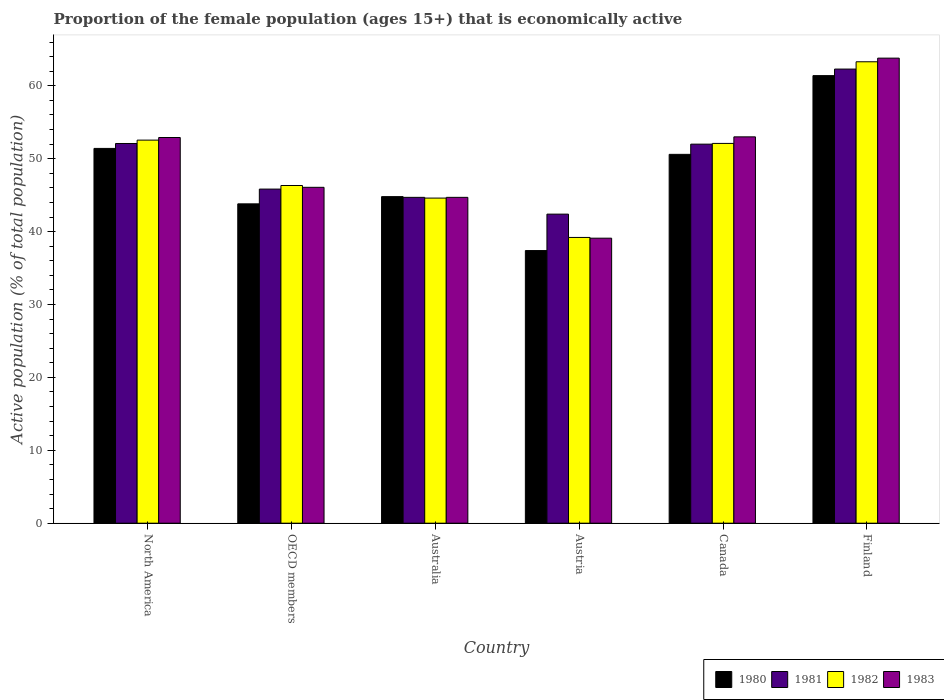How many different coloured bars are there?
Ensure brevity in your answer.  4. How many bars are there on the 3rd tick from the left?
Provide a short and direct response. 4. How many bars are there on the 3rd tick from the right?
Ensure brevity in your answer.  4. What is the label of the 3rd group of bars from the left?
Provide a succinct answer. Australia. In how many cases, is the number of bars for a given country not equal to the number of legend labels?
Ensure brevity in your answer.  0. What is the proportion of the female population that is economically active in 1983 in Canada?
Give a very brief answer. 53. Across all countries, what is the maximum proportion of the female population that is economically active in 1983?
Your response must be concise. 63.8. Across all countries, what is the minimum proportion of the female population that is economically active in 1980?
Provide a succinct answer. 37.4. In which country was the proportion of the female population that is economically active in 1983 maximum?
Your response must be concise. Finland. In which country was the proportion of the female population that is economically active in 1981 minimum?
Offer a very short reply. Austria. What is the total proportion of the female population that is economically active in 1980 in the graph?
Make the answer very short. 289.42. What is the difference between the proportion of the female population that is economically active in 1982 in Canada and that in OECD members?
Your answer should be compact. 5.78. What is the difference between the proportion of the female population that is economically active in 1982 in OECD members and the proportion of the female population that is economically active in 1983 in Canada?
Provide a succinct answer. -6.68. What is the average proportion of the female population that is economically active in 1983 per country?
Offer a very short reply. 49.93. What is the difference between the proportion of the female population that is economically active of/in 1983 and proportion of the female population that is economically active of/in 1982 in Australia?
Give a very brief answer. 0.1. In how many countries, is the proportion of the female population that is economically active in 1983 greater than 64 %?
Provide a succinct answer. 0. What is the ratio of the proportion of the female population that is economically active in 1980 in Finland to that in OECD members?
Offer a terse response. 1.4. Is the proportion of the female population that is economically active in 1981 in Finland less than that in OECD members?
Ensure brevity in your answer.  No. Is the difference between the proportion of the female population that is economically active in 1983 in Australia and Finland greater than the difference between the proportion of the female population that is economically active in 1982 in Australia and Finland?
Provide a short and direct response. No. What is the difference between the highest and the second highest proportion of the female population that is economically active in 1981?
Your response must be concise. -10.21. What is the difference between the highest and the lowest proportion of the female population that is economically active in 1982?
Provide a succinct answer. 24.1. In how many countries, is the proportion of the female population that is economically active in 1982 greater than the average proportion of the female population that is economically active in 1982 taken over all countries?
Offer a very short reply. 3. What does the 1st bar from the left in Australia represents?
Offer a very short reply. 1980. How many bars are there?
Offer a terse response. 24. Are all the bars in the graph horizontal?
Make the answer very short. No. How many countries are there in the graph?
Your response must be concise. 6. Does the graph contain any zero values?
Keep it short and to the point. No. Does the graph contain grids?
Ensure brevity in your answer.  No. How many legend labels are there?
Your answer should be compact. 4. What is the title of the graph?
Keep it short and to the point. Proportion of the female population (ages 15+) that is economically active. What is the label or title of the Y-axis?
Offer a very short reply. Active population (% of total population). What is the Active population (% of total population) in 1980 in North America?
Your answer should be very brief. 51.41. What is the Active population (% of total population) in 1981 in North America?
Provide a short and direct response. 52.09. What is the Active population (% of total population) in 1982 in North America?
Ensure brevity in your answer.  52.55. What is the Active population (% of total population) in 1983 in North America?
Your answer should be compact. 52.91. What is the Active population (% of total population) in 1980 in OECD members?
Offer a terse response. 43.81. What is the Active population (% of total population) in 1981 in OECD members?
Ensure brevity in your answer.  45.84. What is the Active population (% of total population) of 1982 in OECD members?
Your answer should be very brief. 46.32. What is the Active population (% of total population) in 1983 in OECD members?
Your answer should be very brief. 46.08. What is the Active population (% of total population) of 1980 in Australia?
Make the answer very short. 44.8. What is the Active population (% of total population) of 1981 in Australia?
Provide a succinct answer. 44.7. What is the Active population (% of total population) in 1982 in Australia?
Offer a very short reply. 44.6. What is the Active population (% of total population) in 1983 in Australia?
Provide a short and direct response. 44.7. What is the Active population (% of total population) of 1980 in Austria?
Your answer should be compact. 37.4. What is the Active population (% of total population) in 1981 in Austria?
Your answer should be compact. 42.4. What is the Active population (% of total population) of 1982 in Austria?
Provide a succinct answer. 39.2. What is the Active population (% of total population) in 1983 in Austria?
Provide a short and direct response. 39.1. What is the Active population (% of total population) in 1980 in Canada?
Make the answer very short. 50.6. What is the Active population (% of total population) in 1981 in Canada?
Give a very brief answer. 52. What is the Active population (% of total population) of 1982 in Canada?
Give a very brief answer. 52.1. What is the Active population (% of total population) in 1980 in Finland?
Offer a very short reply. 61.4. What is the Active population (% of total population) in 1981 in Finland?
Your answer should be very brief. 62.3. What is the Active population (% of total population) of 1982 in Finland?
Provide a succinct answer. 63.3. What is the Active population (% of total population) in 1983 in Finland?
Provide a short and direct response. 63.8. Across all countries, what is the maximum Active population (% of total population) of 1980?
Your answer should be compact. 61.4. Across all countries, what is the maximum Active population (% of total population) in 1981?
Offer a terse response. 62.3. Across all countries, what is the maximum Active population (% of total population) in 1982?
Offer a very short reply. 63.3. Across all countries, what is the maximum Active population (% of total population) in 1983?
Give a very brief answer. 63.8. Across all countries, what is the minimum Active population (% of total population) of 1980?
Provide a short and direct response. 37.4. Across all countries, what is the minimum Active population (% of total population) in 1981?
Your answer should be compact. 42.4. Across all countries, what is the minimum Active population (% of total population) of 1982?
Provide a short and direct response. 39.2. Across all countries, what is the minimum Active population (% of total population) of 1983?
Make the answer very short. 39.1. What is the total Active population (% of total population) of 1980 in the graph?
Your answer should be compact. 289.42. What is the total Active population (% of total population) in 1981 in the graph?
Ensure brevity in your answer.  299.33. What is the total Active population (% of total population) in 1982 in the graph?
Offer a very short reply. 298.08. What is the total Active population (% of total population) in 1983 in the graph?
Make the answer very short. 299.59. What is the difference between the Active population (% of total population) in 1980 in North America and that in OECD members?
Your answer should be compact. 7.61. What is the difference between the Active population (% of total population) in 1981 in North America and that in OECD members?
Provide a short and direct response. 6.25. What is the difference between the Active population (% of total population) in 1982 in North America and that in OECD members?
Provide a short and direct response. 6.23. What is the difference between the Active population (% of total population) of 1983 in North America and that in OECD members?
Offer a terse response. 6.83. What is the difference between the Active population (% of total population) in 1980 in North America and that in Australia?
Provide a succinct answer. 6.61. What is the difference between the Active population (% of total population) in 1981 in North America and that in Australia?
Your answer should be compact. 7.39. What is the difference between the Active population (% of total population) in 1982 in North America and that in Australia?
Offer a terse response. 7.95. What is the difference between the Active population (% of total population) of 1983 in North America and that in Australia?
Your response must be concise. 8.21. What is the difference between the Active population (% of total population) of 1980 in North America and that in Austria?
Keep it short and to the point. 14.01. What is the difference between the Active population (% of total population) in 1981 in North America and that in Austria?
Ensure brevity in your answer.  9.69. What is the difference between the Active population (% of total population) of 1982 in North America and that in Austria?
Provide a succinct answer. 13.35. What is the difference between the Active population (% of total population) in 1983 in North America and that in Austria?
Your answer should be compact. 13.81. What is the difference between the Active population (% of total population) of 1980 in North America and that in Canada?
Ensure brevity in your answer.  0.81. What is the difference between the Active population (% of total population) in 1981 in North America and that in Canada?
Your answer should be very brief. 0.09. What is the difference between the Active population (% of total population) in 1982 in North America and that in Canada?
Offer a very short reply. 0.45. What is the difference between the Active population (% of total population) in 1983 in North America and that in Canada?
Provide a short and direct response. -0.09. What is the difference between the Active population (% of total population) of 1980 in North America and that in Finland?
Ensure brevity in your answer.  -9.99. What is the difference between the Active population (% of total population) of 1981 in North America and that in Finland?
Ensure brevity in your answer.  -10.21. What is the difference between the Active population (% of total population) in 1982 in North America and that in Finland?
Your response must be concise. -10.75. What is the difference between the Active population (% of total population) of 1983 in North America and that in Finland?
Your answer should be compact. -10.89. What is the difference between the Active population (% of total population) in 1980 in OECD members and that in Australia?
Your response must be concise. -0.99. What is the difference between the Active population (% of total population) in 1981 in OECD members and that in Australia?
Your answer should be very brief. 1.14. What is the difference between the Active population (% of total population) of 1982 in OECD members and that in Australia?
Keep it short and to the point. 1.72. What is the difference between the Active population (% of total population) of 1983 in OECD members and that in Australia?
Your answer should be very brief. 1.38. What is the difference between the Active population (% of total population) of 1980 in OECD members and that in Austria?
Give a very brief answer. 6.41. What is the difference between the Active population (% of total population) in 1981 in OECD members and that in Austria?
Offer a very short reply. 3.44. What is the difference between the Active population (% of total population) in 1982 in OECD members and that in Austria?
Your response must be concise. 7.12. What is the difference between the Active population (% of total population) in 1983 in OECD members and that in Austria?
Your response must be concise. 6.98. What is the difference between the Active population (% of total population) of 1980 in OECD members and that in Canada?
Offer a very short reply. -6.79. What is the difference between the Active population (% of total population) in 1981 in OECD members and that in Canada?
Provide a short and direct response. -6.16. What is the difference between the Active population (% of total population) in 1982 in OECD members and that in Canada?
Provide a succinct answer. -5.78. What is the difference between the Active population (% of total population) of 1983 in OECD members and that in Canada?
Your response must be concise. -6.92. What is the difference between the Active population (% of total population) in 1980 in OECD members and that in Finland?
Give a very brief answer. -17.59. What is the difference between the Active population (% of total population) in 1981 in OECD members and that in Finland?
Give a very brief answer. -16.46. What is the difference between the Active population (% of total population) in 1982 in OECD members and that in Finland?
Your response must be concise. -16.98. What is the difference between the Active population (% of total population) in 1983 in OECD members and that in Finland?
Ensure brevity in your answer.  -17.72. What is the difference between the Active population (% of total population) of 1980 in Australia and that in Canada?
Give a very brief answer. -5.8. What is the difference between the Active population (% of total population) in 1980 in Australia and that in Finland?
Your response must be concise. -16.6. What is the difference between the Active population (% of total population) of 1981 in Australia and that in Finland?
Your answer should be very brief. -17.6. What is the difference between the Active population (% of total population) in 1982 in Australia and that in Finland?
Your answer should be very brief. -18.7. What is the difference between the Active population (% of total population) in 1983 in Australia and that in Finland?
Offer a very short reply. -19.1. What is the difference between the Active population (% of total population) in 1982 in Austria and that in Canada?
Make the answer very short. -12.9. What is the difference between the Active population (% of total population) of 1983 in Austria and that in Canada?
Keep it short and to the point. -13.9. What is the difference between the Active population (% of total population) of 1980 in Austria and that in Finland?
Offer a very short reply. -24. What is the difference between the Active population (% of total population) of 1981 in Austria and that in Finland?
Your answer should be compact. -19.9. What is the difference between the Active population (% of total population) in 1982 in Austria and that in Finland?
Your response must be concise. -24.1. What is the difference between the Active population (% of total population) of 1983 in Austria and that in Finland?
Your answer should be compact. -24.7. What is the difference between the Active population (% of total population) in 1980 in Canada and that in Finland?
Give a very brief answer. -10.8. What is the difference between the Active population (% of total population) of 1981 in Canada and that in Finland?
Give a very brief answer. -10.3. What is the difference between the Active population (% of total population) in 1980 in North America and the Active population (% of total population) in 1981 in OECD members?
Your answer should be very brief. 5.58. What is the difference between the Active population (% of total population) in 1980 in North America and the Active population (% of total population) in 1982 in OECD members?
Your answer should be compact. 5.09. What is the difference between the Active population (% of total population) of 1980 in North America and the Active population (% of total population) of 1983 in OECD members?
Your response must be concise. 5.34. What is the difference between the Active population (% of total population) in 1981 in North America and the Active population (% of total population) in 1982 in OECD members?
Keep it short and to the point. 5.77. What is the difference between the Active population (% of total population) of 1981 in North America and the Active population (% of total population) of 1983 in OECD members?
Your answer should be compact. 6.01. What is the difference between the Active population (% of total population) of 1982 in North America and the Active population (% of total population) of 1983 in OECD members?
Offer a terse response. 6.47. What is the difference between the Active population (% of total population) in 1980 in North America and the Active population (% of total population) in 1981 in Australia?
Your answer should be compact. 6.71. What is the difference between the Active population (% of total population) in 1980 in North America and the Active population (% of total population) in 1982 in Australia?
Make the answer very short. 6.81. What is the difference between the Active population (% of total population) in 1980 in North America and the Active population (% of total population) in 1983 in Australia?
Keep it short and to the point. 6.71. What is the difference between the Active population (% of total population) of 1981 in North America and the Active population (% of total population) of 1982 in Australia?
Make the answer very short. 7.49. What is the difference between the Active population (% of total population) of 1981 in North America and the Active population (% of total population) of 1983 in Australia?
Your answer should be compact. 7.39. What is the difference between the Active population (% of total population) in 1982 in North America and the Active population (% of total population) in 1983 in Australia?
Provide a succinct answer. 7.85. What is the difference between the Active population (% of total population) in 1980 in North America and the Active population (% of total population) in 1981 in Austria?
Provide a short and direct response. 9.01. What is the difference between the Active population (% of total population) of 1980 in North America and the Active population (% of total population) of 1982 in Austria?
Offer a terse response. 12.21. What is the difference between the Active population (% of total population) in 1980 in North America and the Active population (% of total population) in 1983 in Austria?
Provide a succinct answer. 12.31. What is the difference between the Active population (% of total population) in 1981 in North America and the Active population (% of total population) in 1982 in Austria?
Ensure brevity in your answer.  12.89. What is the difference between the Active population (% of total population) of 1981 in North America and the Active population (% of total population) of 1983 in Austria?
Your answer should be compact. 12.99. What is the difference between the Active population (% of total population) of 1982 in North America and the Active population (% of total population) of 1983 in Austria?
Provide a short and direct response. 13.45. What is the difference between the Active population (% of total population) in 1980 in North America and the Active population (% of total population) in 1981 in Canada?
Provide a short and direct response. -0.59. What is the difference between the Active population (% of total population) in 1980 in North America and the Active population (% of total population) in 1982 in Canada?
Make the answer very short. -0.69. What is the difference between the Active population (% of total population) in 1980 in North America and the Active population (% of total population) in 1983 in Canada?
Make the answer very short. -1.59. What is the difference between the Active population (% of total population) in 1981 in North America and the Active population (% of total population) in 1982 in Canada?
Provide a succinct answer. -0.01. What is the difference between the Active population (% of total population) in 1981 in North America and the Active population (% of total population) in 1983 in Canada?
Make the answer very short. -0.91. What is the difference between the Active population (% of total population) of 1982 in North America and the Active population (% of total population) of 1983 in Canada?
Offer a very short reply. -0.45. What is the difference between the Active population (% of total population) in 1980 in North America and the Active population (% of total population) in 1981 in Finland?
Make the answer very short. -10.89. What is the difference between the Active population (% of total population) of 1980 in North America and the Active population (% of total population) of 1982 in Finland?
Make the answer very short. -11.89. What is the difference between the Active population (% of total population) in 1980 in North America and the Active population (% of total population) in 1983 in Finland?
Your answer should be compact. -12.39. What is the difference between the Active population (% of total population) of 1981 in North America and the Active population (% of total population) of 1982 in Finland?
Your answer should be compact. -11.21. What is the difference between the Active population (% of total population) in 1981 in North America and the Active population (% of total population) in 1983 in Finland?
Provide a succinct answer. -11.71. What is the difference between the Active population (% of total population) of 1982 in North America and the Active population (% of total population) of 1983 in Finland?
Offer a very short reply. -11.25. What is the difference between the Active population (% of total population) in 1980 in OECD members and the Active population (% of total population) in 1981 in Australia?
Make the answer very short. -0.89. What is the difference between the Active population (% of total population) in 1980 in OECD members and the Active population (% of total population) in 1982 in Australia?
Make the answer very short. -0.79. What is the difference between the Active population (% of total population) in 1980 in OECD members and the Active population (% of total population) in 1983 in Australia?
Offer a terse response. -0.89. What is the difference between the Active population (% of total population) of 1981 in OECD members and the Active population (% of total population) of 1982 in Australia?
Provide a short and direct response. 1.24. What is the difference between the Active population (% of total population) of 1981 in OECD members and the Active population (% of total population) of 1983 in Australia?
Give a very brief answer. 1.14. What is the difference between the Active population (% of total population) of 1982 in OECD members and the Active population (% of total population) of 1983 in Australia?
Provide a succinct answer. 1.62. What is the difference between the Active population (% of total population) in 1980 in OECD members and the Active population (% of total population) in 1981 in Austria?
Keep it short and to the point. 1.41. What is the difference between the Active population (% of total population) in 1980 in OECD members and the Active population (% of total population) in 1982 in Austria?
Offer a terse response. 4.61. What is the difference between the Active population (% of total population) in 1980 in OECD members and the Active population (% of total population) in 1983 in Austria?
Make the answer very short. 4.71. What is the difference between the Active population (% of total population) in 1981 in OECD members and the Active population (% of total population) in 1982 in Austria?
Give a very brief answer. 6.64. What is the difference between the Active population (% of total population) in 1981 in OECD members and the Active population (% of total population) in 1983 in Austria?
Your answer should be very brief. 6.74. What is the difference between the Active population (% of total population) of 1982 in OECD members and the Active population (% of total population) of 1983 in Austria?
Your answer should be compact. 7.22. What is the difference between the Active population (% of total population) of 1980 in OECD members and the Active population (% of total population) of 1981 in Canada?
Ensure brevity in your answer.  -8.19. What is the difference between the Active population (% of total population) in 1980 in OECD members and the Active population (% of total population) in 1982 in Canada?
Provide a short and direct response. -8.29. What is the difference between the Active population (% of total population) of 1980 in OECD members and the Active population (% of total population) of 1983 in Canada?
Provide a short and direct response. -9.19. What is the difference between the Active population (% of total population) of 1981 in OECD members and the Active population (% of total population) of 1982 in Canada?
Provide a short and direct response. -6.26. What is the difference between the Active population (% of total population) in 1981 in OECD members and the Active population (% of total population) in 1983 in Canada?
Make the answer very short. -7.16. What is the difference between the Active population (% of total population) of 1982 in OECD members and the Active population (% of total population) of 1983 in Canada?
Keep it short and to the point. -6.68. What is the difference between the Active population (% of total population) of 1980 in OECD members and the Active population (% of total population) of 1981 in Finland?
Your answer should be very brief. -18.49. What is the difference between the Active population (% of total population) in 1980 in OECD members and the Active population (% of total population) in 1982 in Finland?
Keep it short and to the point. -19.49. What is the difference between the Active population (% of total population) of 1980 in OECD members and the Active population (% of total population) of 1983 in Finland?
Provide a succinct answer. -19.99. What is the difference between the Active population (% of total population) of 1981 in OECD members and the Active population (% of total population) of 1982 in Finland?
Ensure brevity in your answer.  -17.46. What is the difference between the Active population (% of total population) in 1981 in OECD members and the Active population (% of total population) in 1983 in Finland?
Offer a terse response. -17.96. What is the difference between the Active population (% of total population) of 1982 in OECD members and the Active population (% of total population) of 1983 in Finland?
Your response must be concise. -17.48. What is the difference between the Active population (% of total population) in 1980 in Australia and the Active population (% of total population) in 1981 in Austria?
Ensure brevity in your answer.  2.4. What is the difference between the Active population (% of total population) of 1980 in Australia and the Active population (% of total population) of 1982 in Austria?
Your answer should be compact. 5.6. What is the difference between the Active population (% of total population) of 1981 in Australia and the Active population (% of total population) of 1983 in Austria?
Your response must be concise. 5.6. What is the difference between the Active population (% of total population) of 1980 in Australia and the Active population (% of total population) of 1981 in Canada?
Your answer should be compact. -7.2. What is the difference between the Active population (% of total population) in 1981 in Australia and the Active population (% of total population) in 1982 in Canada?
Your answer should be compact. -7.4. What is the difference between the Active population (% of total population) in 1981 in Australia and the Active population (% of total population) in 1983 in Canada?
Your answer should be compact. -8.3. What is the difference between the Active population (% of total population) in 1980 in Australia and the Active population (% of total population) in 1981 in Finland?
Provide a succinct answer. -17.5. What is the difference between the Active population (% of total population) in 1980 in Australia and the Active population (% of total population) in 1982 in Finland?
Provide a short and direct response. -18.5. What is the difference between the Active population (% of total population) in 1980 in Australia and the Active population (% of total population) in 1983 in Finland?
Ensure brevity in your answer.  -19. What is the difference between the Active population (% of total population) in 1981 in Australia and the Active population (% of total population) in 1982 in Finland?
Provide a short and direct response. -18.6. What is the difference between the Active population (% of total population) of 1981 in Australia and the Active population (% of total population) of 1983 in Finland?
Ensure brevity in your answer.  -19.1. What is the difference between the Active population (% of total population) in 1982 in Australia and the Active population (% of total population) in 1983 in Finland?
Your response must be concise. -19.2. What is the difference between the Active population (% of total population) of 1980 in Austria and the Active population (% of total population) of 1981 in Canada?
Give a very brief answer. -14.6. What is the difference between the Active population (% of total population) in 1980 in Austria and the Active population (% of total population) in 1982 in Canada?
Your response must be concise. -14.7. What is the difference between the Active population (% of total population) in 1980 in Austria and the Active population (% of total population) in 1983 in Canada?
Give a very brief answer. -15.6. What is the difference between the Active population (% of total population) in 1981 in Austria and the Active population (% of total population) in 1982 in Canada?
Keep it short and to the point. -9.7. What is the difference between the Active population (% of total population) of 1981 in Austria and the Active population (% of total population) of 1983 in Canada?
Provide a short and direct response. -10.6. What is the difference between the Active population (% of total population) in 1980 in Austria and the Active population (% of total population) in 1981 in Finland?
Provide a succinct answer. -24.9. What is the difference between the Active population (% of total population) of 1980 in Austria and the Active population (% of total population) of 1982 in Finland?
Offer a very short reply. -25.9. What is the difference between the Active population (% of total population) in 1980 in Austria and the Active population (% of total population) in 1983 in Finland?
Your answer should be very brief. -26.4. What is the difference between the Active population (% of total population) in 1981 in Austria and the Active population (% of total population) in 1982 in Finland?
Your response must be concise. -20.9. What is the difference between the Active population (% of total population) in 1981 in Austria and the Active population (% of total population) in 1983 in Finland?
Make the answer very short. -21.4. What is the difference between the Active population (% of total population) of 1982 in Austria and the Active population (% of total population) of 1983 in Finland?
Provide a short and direct response. -24.6. What is the difference between the Active population (% of total population) of 1980 in Canada and the Active population (% of total population) of 1983 in Finland?
Make the answer very short. -13.2. What is the difference between the Active population (% of total population) in 1981 in Canada and the Active population (% of total population) in 1983 in Finland?
Offer a terse response. -11.8. What is the average Active population (% of total population) in 1980 per country?
Offer a very short reply. 48.24. What is the average Active population (% of total population) of 1981 per country?
Ensure brevity in your answer.  49.89. What is the average Active population (% of total population) of 1982 per country?
Your response must be concise. 49.68. What is the average Active population (% of total population) of 1983 per country?
Your answer should be compact. 49.93. What is the difference between the Active population (% of total population) of 1980 and Active population (% of total population) of 1981 in North America?
Offer a terse response. -0.68. What is the difference between the Active population (% of total population) in 1980 and Active population (% of total population) in 1982 in North America?
Offer a terse response. -1.14. What is the difference between the Active population (% of total population) in 1980 and Active population (% of total population) in 1983 in North America?
Make the answer very short. -1.5. What is the difference between the Active population (% of total population) of 1981 and Active population (% of total population) of 1982 in North America?
Your answer should be very brief. -0.46. What is the difference between the Active population (% of total population) of 1981 and Active population (% of total population) of 1983 in North America?
Your response must be concise. -0.82. What is the difference between the Active population (% of total population) of 1982 and Active population (% of total population) of 1983 in North America?
Make the answer very short. -0.36. What is the difference between the Active population (% of total population) in 1980 and Active population (% of total population) in 1981 in OECD members?
Ensure brevity in your answer.  -2.03. What is the difference between the Active population (% of total population) in 1980 and Active population (% of total population) in 1982 in OECD members?
Provide a succinct answer. -2.52. What is the difference between the Active population (% of total population) of 1980 and Active population (% of total population) of 1983 in OECD members?
Offer a terse response. -2.27. What is the difference between the Active population (% of total population) in 1981 and Active population (% of total population) in 1982 in OECD members?
Make the answer very short. -0.49. What is the difference between the Active population (% of total population) in 1981 and Active population (% of total population) in 1983 in OECD members?
Provide a succinct answer. -0.24. What is the difference between the Active population (% of total population) of 1982 and Active population (% of total population) of 1983 in OECD members?
Offer a very short reply. 0.25. What is the difference between the Active population (% of total population) of 1980 and Active population (% of total population) of 1982 in Australia?
Give a very brief answer. 0.2. What is the difference between the Active population (% of total population) of 1981 and Active population (% of total population) of 1982 in Australia?
Your answer should be very brief. 0.1. What is the difference between the Active population (% of total population) of 1981 and Active population (% of total population) of 1983 in Australia?
Your answer should be very brief. 0. What is the difference between the Active population (% of total population) in 1981 and Active population (% of total population) in 1983 in Austria?
Make the answer very short. 3.3. What is the difference between the Active population (% of total population) in 1982 and Active population (% of total population) in 1983 in Austria?
Keep it short and to the point. 0.1. What is the difference between the Active population (% of total population) in 1980 and Active population (% of total population) in 1982 in Canada?
Ensure brevity in your answer.  -1.5. What is the difference between the Active population (% of total population) in 1980 and Active population (% of total population) in 1983 in Canada?
Your response must be concise. -2.4. What is the difference between the Active population (% of total population) in 1981 and Active population (% of total population) in 1983 in Canada?
Provide a short and direct response. -1. What is the difference between the Active population (% of total population) in 1980 and Active population (% of total population) in 1982 in Finland?
Give a very brief answer. -1.9. What is the ratio of the Active population (% of total population) of 1980 in North America to that in OECD members?
Your response must be concise. 1.17. What is the ratio of the Active population (% of total population) of 1981 in North America to that in OECD members?
Your answer should be very brief. 1.14. What is the ratio of the Active population (% of total population) of 1982 in North America to that in OECD members?
Your answer should be compact. 1.13. What is the ratio of the Active population (% of total population) of 1983 in North America to that in OECD members?
Make the answer very short. 1.15. What is the ratio of the Active population (% of total population) of 1980 in North America to that in Australia?
Offer a terse response. 1.15. What is the ratio of the Active population (% of total population) of 1981 in North America to that in Australia?
Offer a terse response. 1.17. What is the ratio of the Active population (% of total population) in 1982 in North America to that in Australia?
Keep it short and to the point. 1.18. What is the ratio of the Active population (% of total population) of 1983 in North America to that in Australia?
Ensure brevity in your answer.  1.18. What is the ratio of the Active population (% of total population) of 1980 in North America to that in Austria?
Give a very brief answer. 1.37. What is the ratio of the Active population (% of total population) in 1981 in North America to that in Austria?
Ensure brevity in your answer.  1.23. What is the ratio of the Active population (% of total population) of 1982 in North America to that in Austria?
Offer a terse response. 1.34. What is the ratio of the Active population (% of total population) of 1983 in North America to that in Austria?
Your answer should be compact. 1.35. What is the ratio of the Active population (% of total population) in 1980 in North America to that in Canada?
Provide a short and direct response. 1.02. What is the ratio of the Active population (% of total population) in 1981 in North America to that in Canada?
Your answer should be compact. 1. What is the ratio of the Active population (% of total population) of 1982 in North America to that in Canada?
Provide a short and direct response. 1.01. What is the ratio of the Active population (% of total population) in 1980 in North America to that in Finland?
Keep it short and to the point. 0.84. What is the ratio of the Active population (% of total population) in 1981 in North America to that in Finland?
Offer a terse response. 0.84. What is the ratio of the Active population (% of total population) in 1982 in North America to that in Finland?
Your response must be concise. 0.83. What is the ratio of the Active population (% of total population) of 1983 in North America to that in Finland?
Provide a succinct answer. 0.83. What is the ratio of the Active population (% of total population) of 1980 in OECD members to that in Australia?
Your response must be concise. 0.98. What is the ratio of the Active population (% of total population) in 1981 in OECD members to that in Australia?
Provide a succinct answer. 1.03. What is the ratio of the Active population (% of total population) in 1982 in OECD members to that in Australia?
Provide a short and direct response. 1.04. What is the ratio of the Active population (% of total population) in 1983 in OECD members to that in Australia?
Give a very brief answer. 1.03. What is the ratio of the Active population (% of total population) of 1980 in OECD members to that in Austria?
Ensure brevity in your answer.  1.17. What is the ratio of the Active population (% of total population) of 1981 in OECD members to that in Austria?
Your response must be concise. 1.08. What is the ratio of the Active population (% of total population) of 1982 in OECD members to that in Austria?
Offer a very short reply. 1.18. What is the ratio of the Active population (% of total population) of 1983 in OECD members to that in Austria?
Provide a short and direct response. 1.18. What is the ratio of the Active population (% of total population) in 1980 in OECD members to that in Canada?
Your response must be concise. 0.87. What is the ratio of the Active population (% of total population) in 1981 in OECD members to that in Canada?
Offer a terse response. 0.88. What is the ratio of the Active population (% of total population) in 1982 in OECD members to that in Canada?
Offer a very short reply. 0.89. What is the ratio of the Active population (% of total population) in 1983 in OECD members to that in Canada?
Make the answer very short. 0.87. What is the ratio of the Active population (% of total population) in 1980 in OECD members to that in Finland?
Keep it short and to the point. 0.71. What is the ratio of the Active population (% of total population) of 1981 in OECD members to that in Finland?
Give a very brief answer. 0.74. What is the ratio of the Active population (% of total population) in 1982 in OECD members to that in Finland?
Your answer should be very brief. 0.73. What is the ratio of the Active population (% of total population) in 1983 in OECD members to that in Finland?
Your response must be concise. 0.72. What is the ratio of the Active population (% of total population) of 1980 in Australia to that in Austria?
Make the answer very short. 1.2. What is the ratio of the Active population (% of total population) of 1981 in Australia to that in Austria?
Provide a short and direct response. 1.05. What is the ratio of the Active population (% of total population) in 1982 in Australia to that in Austria?
Give a very brief answer. 1.14. What is the ratio of the Active population (% of total population) in 1983 in Australia to that in Austria?
Provide a succinct answer. 1.14. What is the ratio of the Active population (% of total population) of 1980 in Australia to that in Canada?
Your answer should be compact. 0.89. What is the ratio of the Active population (% of total population) of 1981 in Australia to that in Canada?
Your answer should be very brief. 0.86. What is the ratio of the Active population (% of total population) in 1982 in Australia to that in Canada?
Keep it short and to the point. 0.86. What is the ratio of the Active population (% of total population) in 1983 in Australia to that in Canada?
Keep it short and to the point. 0.84. What is the ratio of the Active population (% of total population) of 1980 in Australia to that in Finland?
Offer a terse response. 0.73. What is the ratio of the Active population (% of total population) in 1981 in Australia to that in Finland?
Ensure brevity in your answer.  0.72. What is the ratio of the Active population (% of total population) in 1982 in Australia to that in Finland?
Provide a short and direct response. 0.7. What is the ratio of the Active population (% of total population) of 1983 in Australia to that in Finland?
Ensure brevity in your answer.  0.7. What is the ratio of the Active population (% of total population) in 1980 in Austria to that in Canada?
Your response must be concise. 0.74. What is the ratio of the Active population (% of total population) in 1981 in Austria to that in Canada?
Your response must be concise. 0.82. What is the ratio of the Active population (% of total population) of 1982 in Austria to that in Canada?
Offer a terse response. 0.75. What is the ratio of the Active population (% of total population) of 1983 in Austria to that in Canada?
Your answer should be very brief. 0.74. What is the ratio of the Active population (% of total population) of 1980 in Austria to that in Finland?
Ensure brevity in your answer.  0.61. What is the ratio of the Active population (% of total population) of 1981 in Austria to that in Finland?
Offer a very short reply. 0.68. What is the ratio of the Active population (% of total population) in 1982 in Austria to that in Finland?
Offer a terse response. 0.62. What is the ratio of the Active population (% of total population) in 1983 in Austria to that in Finland?
Your answer should be compact. 0.61. What is the ratio of the Active population (% of total population) in 1980 in Canada to that in Finland?
Your answer should be very brief. 0.82. What is the ratio of the Active population (% of total population) in 1981 in Canada to that in Finland?
Your response must be concise. 0.83. What is the ratio of the Active population (% of total population) in 1982 in Canada to that in Finland?
Give a very brief answer. 0.82. What is the ratio of the Active population (% of total population) of 1983 in Canada to that in Finland?
Provide a succinct answer. 0.83. What is the difference between the highest and the second highest Active population (% of total population) of 1980?
Provide a succinct answer. 9.99. What is the difference between the highest and the second highest Active population (% of total population) of 1981?
Offer a terse response. 10.21. What is the difference between the highest and the second highest Active population (% of total population) in 1982?
Your answer should be very brief. 10.75. What is the difference between the highest and the lowest Active population (% of total population) in 1980?
Give a very brief answer. 24. What is the difference between the highest and the lowest Active population (% of total population) in 1982?
Keep it short and to the point. 24.1. What is the difference between the highest and the lowest Active population (% of total population) in 1983?
Offer a very short reply. 24.7. 